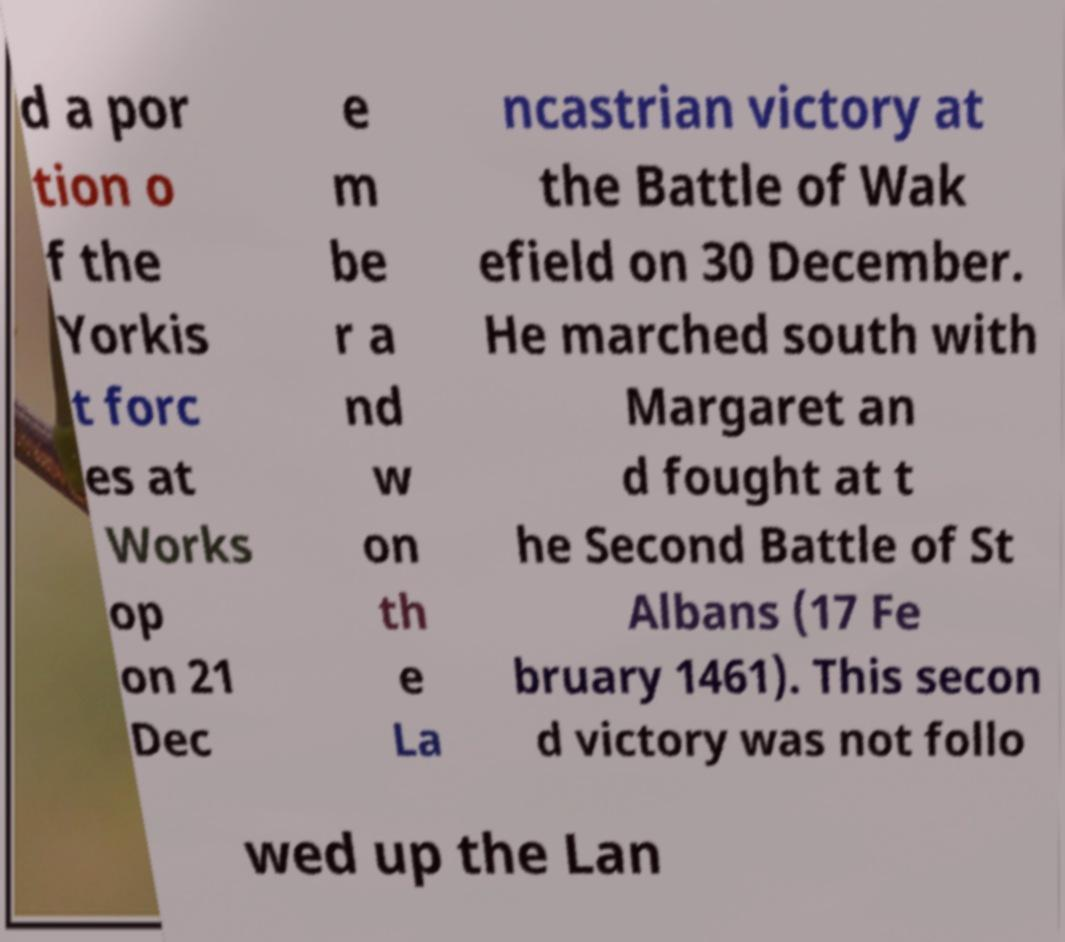Please identify and transcribe the text found in this image. d a por tion o f the Yorkis t forc es at Works op on 21 Dec e m be r a nd w on th e La ncastrian victory at the Battle of Wak efield on 30 December. He marched south with Margaret an d fought at t he Second Battle of St Albans (17 Fe bruary 1461). This secon d victory was not follo wed up the Lan 